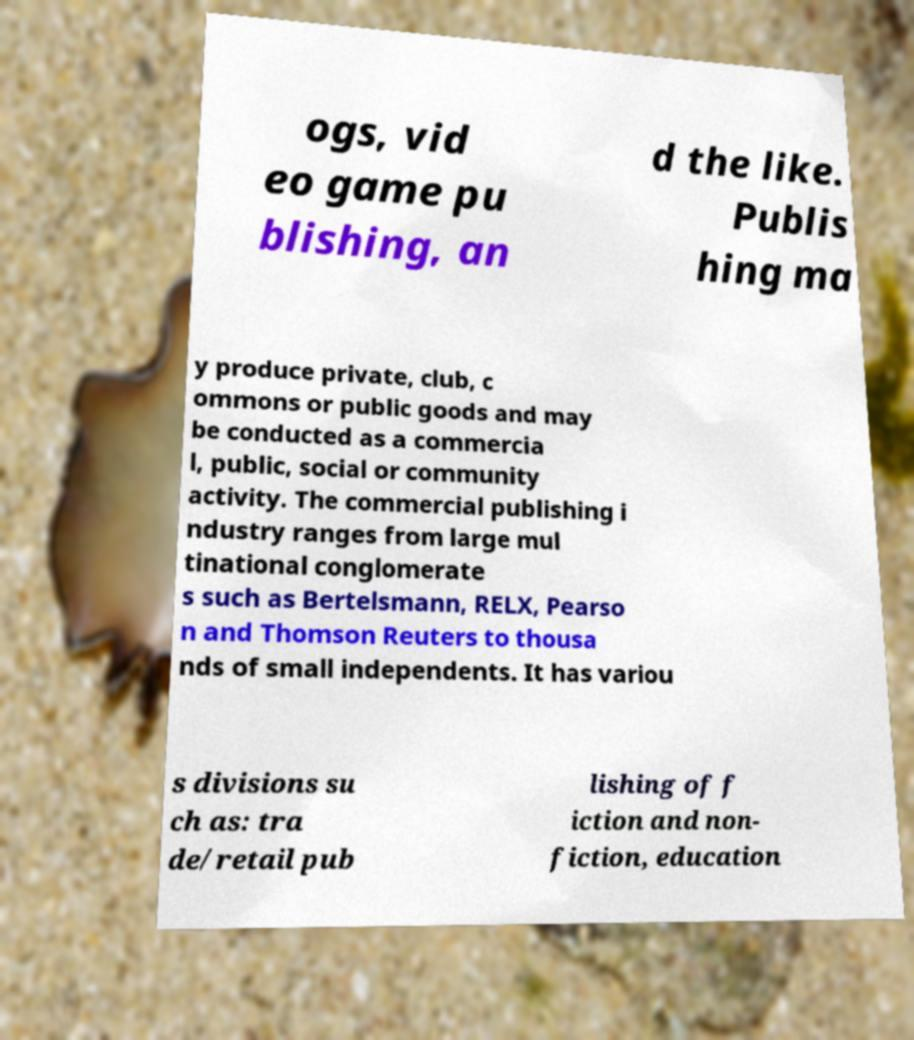Please identify and transcribe the text found in this image. ogs, vid eo game pu blishing, an d the like. Publis hing ma y produce private, club, c ommons or public goods and may be conducted as a commercia l, public, social or community activity. The commercial publishing i ndustry ranges from large mul tinational conglomerate s such as Bertelsmann, RELX, Pearso n and Thomson Reuters to thousa nds of small independents. It has variou s divisions su ch as: tra de/retail pub lishing of f iction and non- fiction, education 